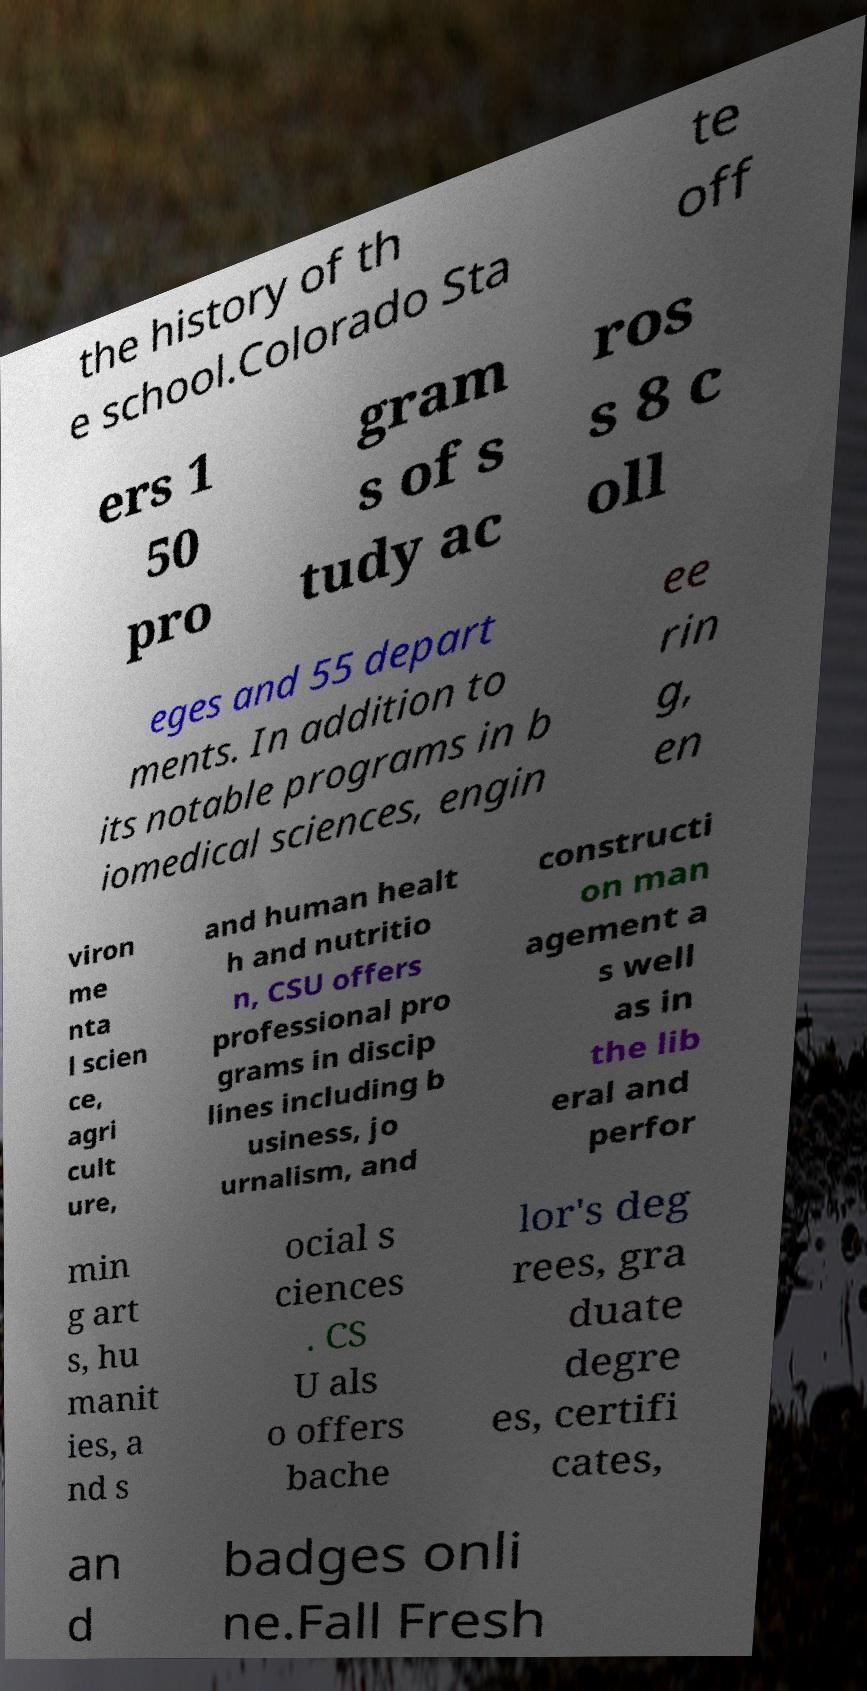Please identify and transcribe the text found in this image. the history of th e school.Colorado Sta te off ers 1 50 pro gram s of s tudy ac ros s 8 c oll eges and 55 depart ments. In addition to its notable programs in b iomedical sciences, engin ee rin g, en viron me nta l scien ce, agri cult ure, and human healt h and nutritio n, CSU offers professional pro grams in discip lines including b usiness, jo urnalism, and constructi on man agement a s well as in the lib eral and perfor min g art s, hu manit ies, a nd s ocial s ciences . CS U als o offers bache lor's deg rees, gra duate degre es, certifi cates, an d badges onli ne.Fall Fresh 